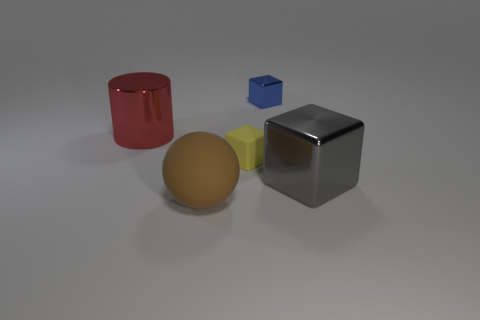Add 3 big gray metallic balls. How many objects exist? 8 Subtract all spheres. How many objects are left? 4 Add 3 big blue objects. How many big blue objects exist? 3 Subtract 0 green balls. How many objects are left? 5 Subtract all small rubber things. Subtract all large cylinders. How many objects are left? 3 Add 3 tiny metal things. How many tiny metal things are left? 4 